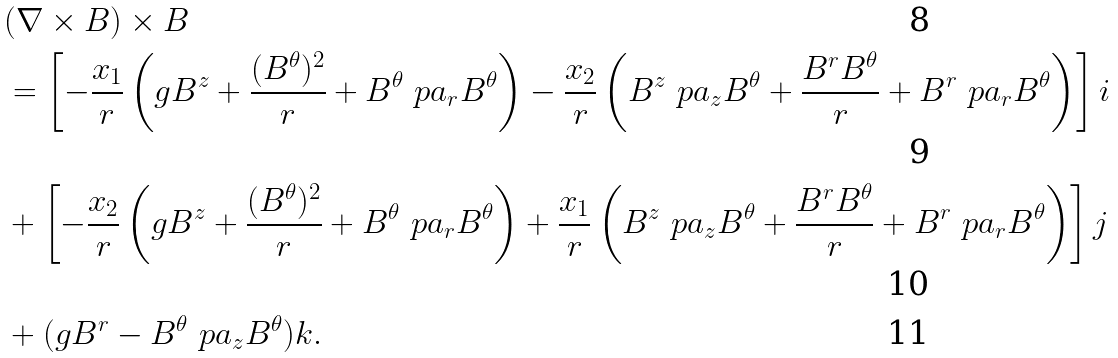Convert formula to latex. <formula><loc_0><loc_0><loc_500><loc_500>& ( \nabla \times { B } ) \times { B } \\ & = \left [ - \frac { x _ { 1 } } { r } \left ( g B ^ { z } + \frac { ( B ^ { \theta } ) ^ { 2 } } { r } + B ^ { \theta } \ p a _ { r } B ^ { \theta } \right ) - \frac { x _ { 2 } } { r } \left ( B ^ { z } \ p a _ { z } B ^ { \theta } + \frac { B ^ { r } B ^ { \theta } } { r } + B ^ { r } \ p a _ { r } B ^ { \theta } \right ) \right ] { i } \\ & + \left [ - \frac { x _ { 2 } } { r } \left ( g B ^ { z } + \frac { ( B ^ { \theta } ) ^ { 2 } } { r } + B ^ { \theta } \ p a _ { r } B ^ { \theta } \right ) + \frac { x _ { 1 } } { r } \left ( B ^ { z } \ p a _ { z } B ^ { \theta } + \frac { B ^ { r } B ^ { \theta } } { r } + B ^ { r } \ p a _ { r } B ^ { \theta } \right ) \right ] { j } \\ & + ( g B ^ { r } - B ^ { \theta } \ p a _ { z } B ^ { \theta } ) { k } .</formula> 